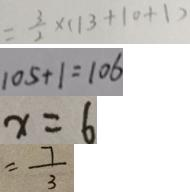Convert formula to latex. <formula><loc_0><loc_0><loc_500><loc_500>= \frac { 3 } { 2 } \times ( 1 3 + 1 0 + 1 ) 
 1 0 5 + 1 = 1 0 6 
 x = 6 
 = \frac { 7 } { 3 }</formula> 